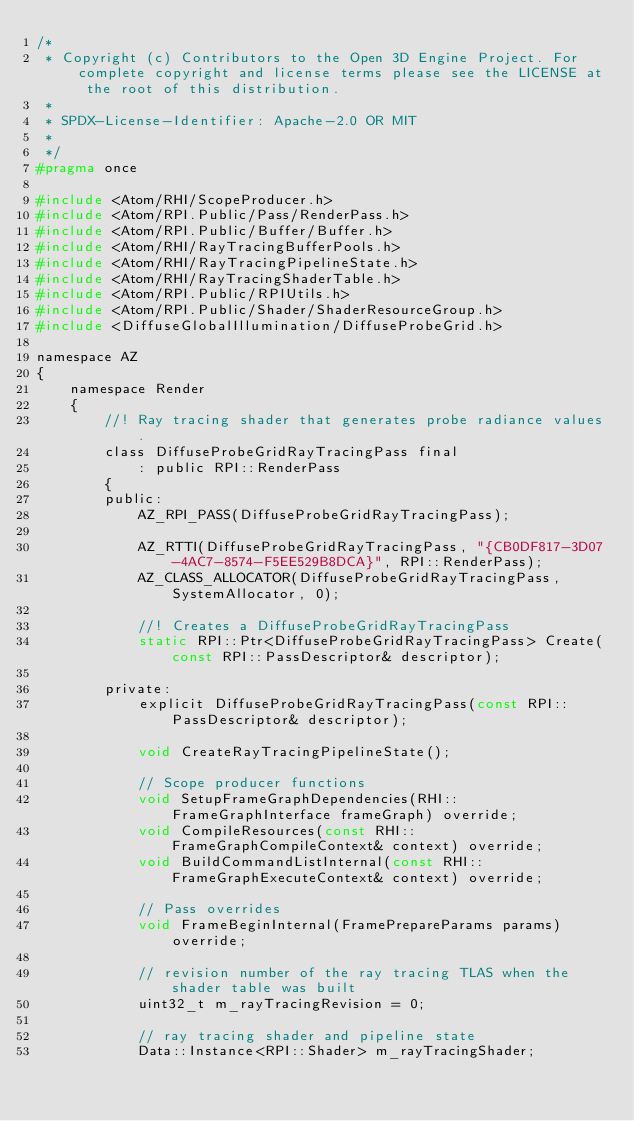<code> <loc_0><loc_0><loc_500><loc_500><_C_>/*
 * Copyright (c) Contributors to the Open 3D Engine Project. For complete copyright and license terms please see the LICENSE at the root of this distribution.
 * 
 * SPDX-License-Identifier: Apache-2.0 OR MIT
 *
 */
#pragma once

#include <Atom/RHI/ScopeProducer.h>
#include <Atom/RPI.Public/Pass/RenderPass.h>
#include <Atom/RPI.Public/Buffer/Buffer.h>
#include <Atom/RHI/RayTracingBufferPools.h>
#include <Atom/RHI/RayTracingPipelineState.h>
#include <Atom/RHI/RayTracingShaderTable.h>
#include <Atom/RPI.Public/RPIUtils.h>
#include <Atom/RPI.Public/Shader/ShaderResourceGroup.h>
#include <DiffuseGlobalIllumination/DiffuseProbeGrid.h>

namespace AZ
{
    namespace Render
    {
        //! Ray tracing shader that generates probe radiance values.
        class DiffuseProbeGridRayTracingPass final
            : public RPI::RenderPass
        {
        public:
            AZ_RPI_PASS(DiffuseProbeGridRayTracingPass);

            AZ_RTTI(DiffuseProbeGridRayTracingPass, "{CB0DF817-3D07-4AC7-8574-F5EE529B8DCA}", RPI::RenderPass);
            AZ_CLASS_ALLOCATOR(DiffuseProbeGridRayTracingPass, SystemAllocator, 0);

            //! Creates a DiffuseProbeGridRayTracingPass
            static RPI::Ptr<DiffuseProbeGridRayTracingPass> Create(const RPI::PassDescriptor& descriptor);

        private:
            explicit DiffuseProbeGridRayTracingPass(const RPI::PassDescriptor& descriptor);

            void CreateRayTracingPipelineState();

            // Scope producer functions
            void SetupFrameGraphDependencies(RHI::FrameGraphInterface frameGraph) override;
            void CompileResources(const RHI::FrameGraphCompileContext& context) override;
            void BuildCommandListInternal(const RHI::FrameGraphExecuteContext& context) override;

            // Pass overrides
            void FrameBeginInternal(FramePrepareParams params) override;

            // revision number of the ray tracing TLAS when the shader table was built
            uint32_t m_rayTracingRevision = 0;

            // ray tracing shader and pipeline state
            Data::Instance<RPI::Shader> m_rayTracingShader;</code> 